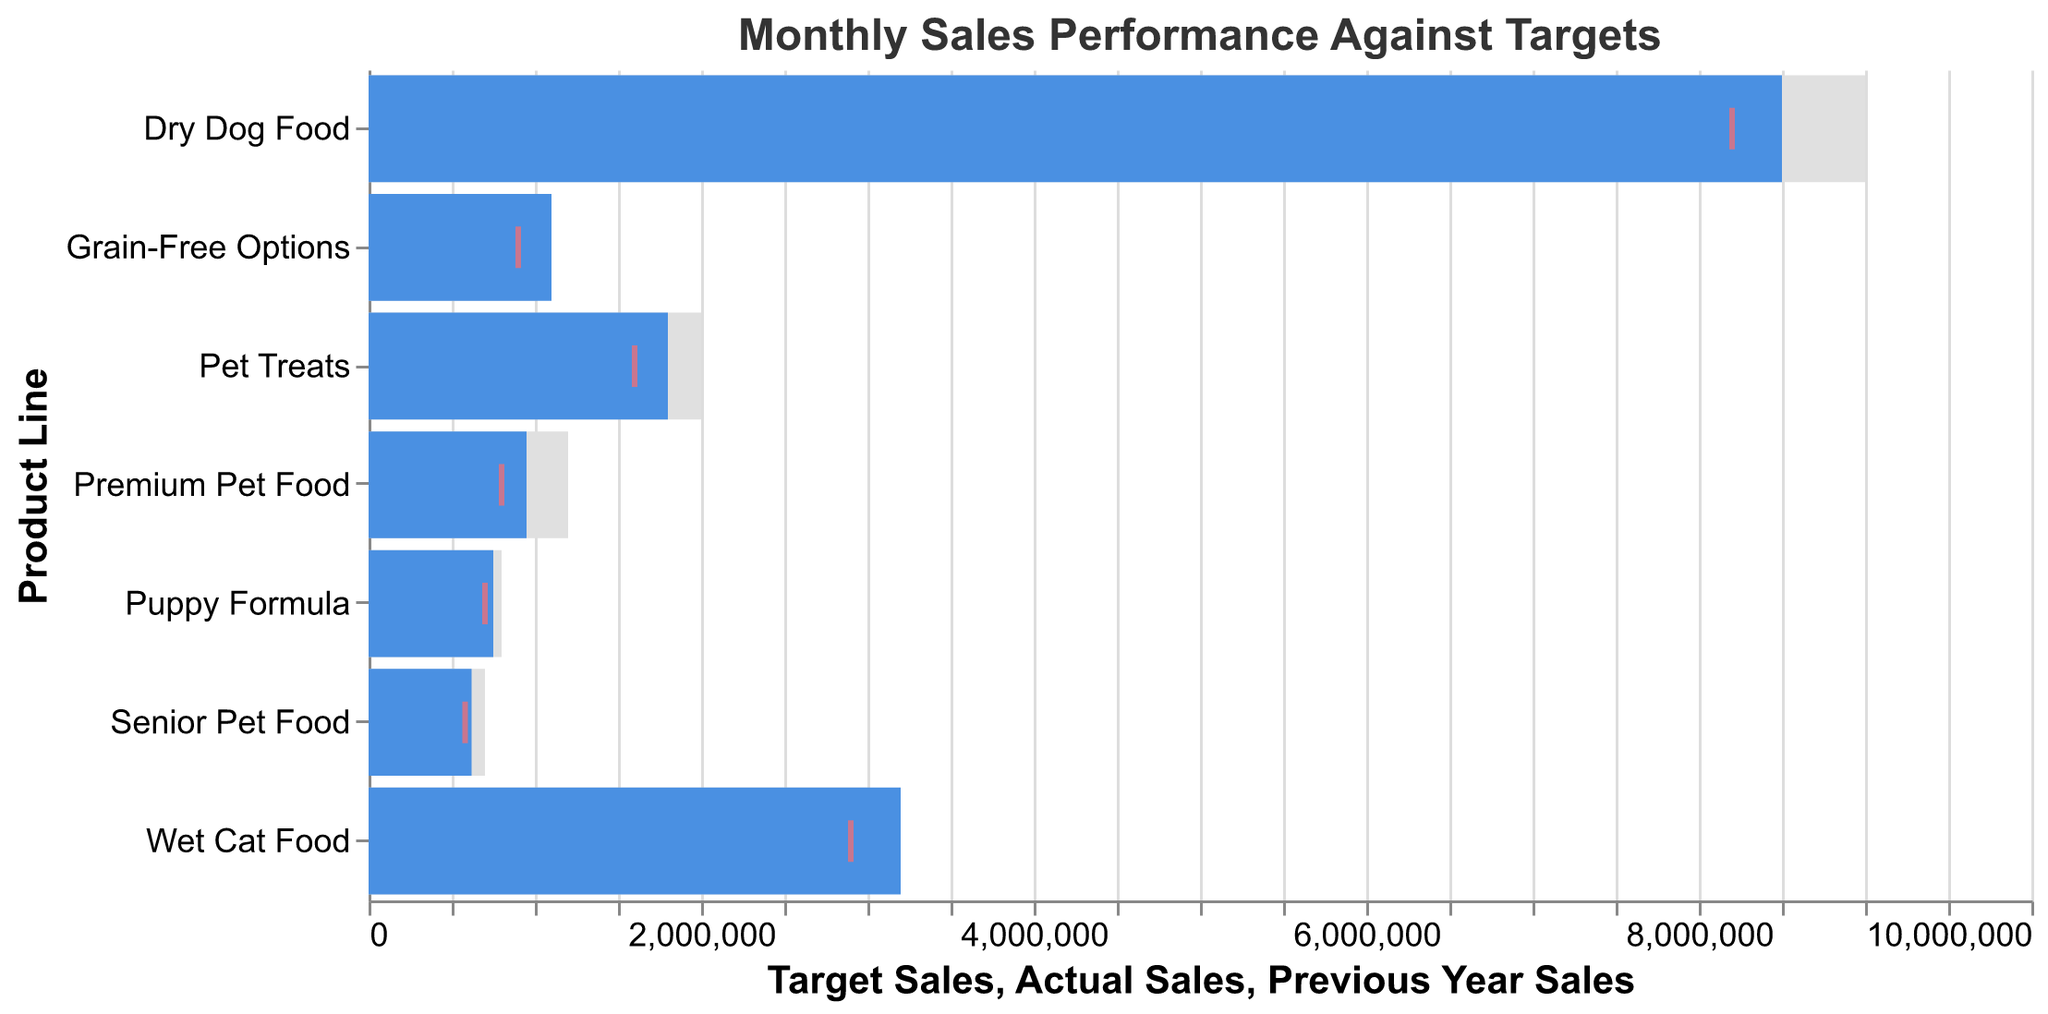What's the title of the chart? The title is typically displayed at the top of the chart. It summarizes what the chart is about. In this case, it specifies the data being shown and the time period.
Answer: Monthly Sales Performance Against Targets Which product line has the highest actual sales? To find this, compare the heights of the blue bars (which represent actual sales) for all product lines.
Answer: Dry Dog Food Which product line exceeds its target sales the most? Look for the product line where the blue bar (actual sales) surpasses the gray bar (target sales) by the largest margin.
Answer: Wet Cat Food How do actual sales for Premium Pet Food compare to its target sales? Compare the length of the blue bar (actual sales) to the gray bar (target sales). The blue bar falls short of the gray bar indicating actual sales are below target.
Answer: Below target What is the previous year sales value for Puppy Formula? Locate the red tick mark corresponding to Puppy Formula; it shows the previous year sales value.
Answer: 700,000 Which product lines have actual sales below their target sales? Identify the product lines where the blue bar (actual sales) is shorter than the gray bar (target sales).
Answer: Dry Dog Food, Pet Treats, Premium Pet Food, Puppy Formula, Senior Pet Food What’s the difference in actual sales between Dry Dog Food and Wet Cat Food? Subtract the actual sales of Wet Cat Food from the actual sales of Dry Dog Food (8,500,000 - 3,200,000).
Answer: 5,300,000 How do Grain-Free Options perform compared to the previous year? Compare the blue bar (actual sales) to the red tick mark (previous year sales) for Grain-Free Options.
Answer: Above previous year Are there any products where actual sales improved compared to the previous year but still fell short of the target? Look for product lines where the blue bar (actual sales) exceeds the red tick mark (previous year sales) but is below the gray bar (target sales).
Answer: Dry Dog Food, Pet Treats, Premium Pet Food, Puppy Formula, Senior Pet Food Which product line has the smallest difference between actual and target sales? Calculate the difference between actual sales and target sales for each product line and find the smallest one (absolute difference). For example, Dry Dog Food (9,000,000 - 8,500,000 = 500,000), Wet Cat Food (300,000), Pet Treats (200,000), Premium Pet Food (250,000), Puppy Formula (50,000), Senior Pet Food (80,000), Grain-Free Options (100,000).
Answer: Puppy Formula 